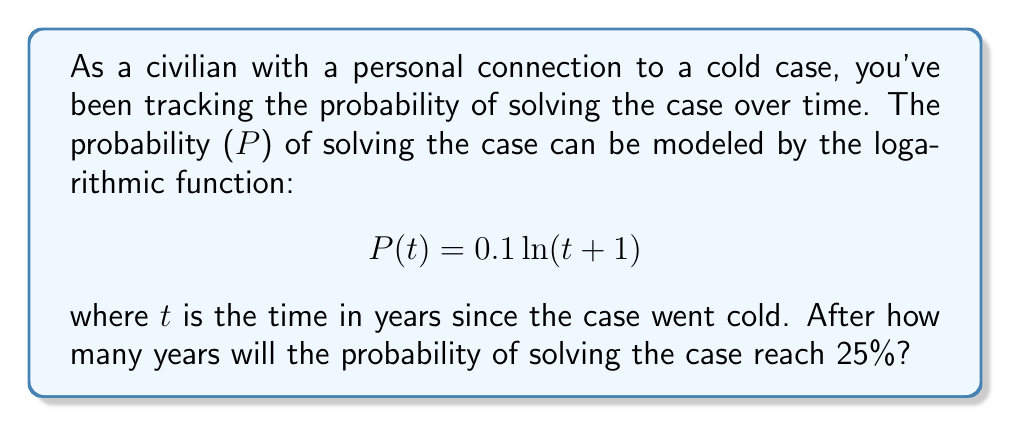Help me with this question. To solve this problem, we need to use the given logarithmic function and find the value of t when P(t) = 0.25 (25%).

1) Set up the equation:
   $$ 0.25 = 0.1 \ln(t + 1) $$

2) Divide both sides by 0.1:
   $$ 2.5 = \ln(t + 1) $$

3) Apply the exponential function (e^x) to both sides to isolate t + 1:
   $$ e^{2.5} = e^{\ln(t + 1)} = t + 1 $$

4) Simplify:
   $$ e^{2.5} = t + 1 $$

5) Subtract 1 from both sides:
   $$ e^{2.5} - 1 = t $$

6) Calculate the value (use a calculator):
   $$ t \approx 11.18 $$

7) Since we're dealing with years, we round up to the nearest whole year.
Answer: It will take 12 years for the probability of solving the cold case to reach 25%. 